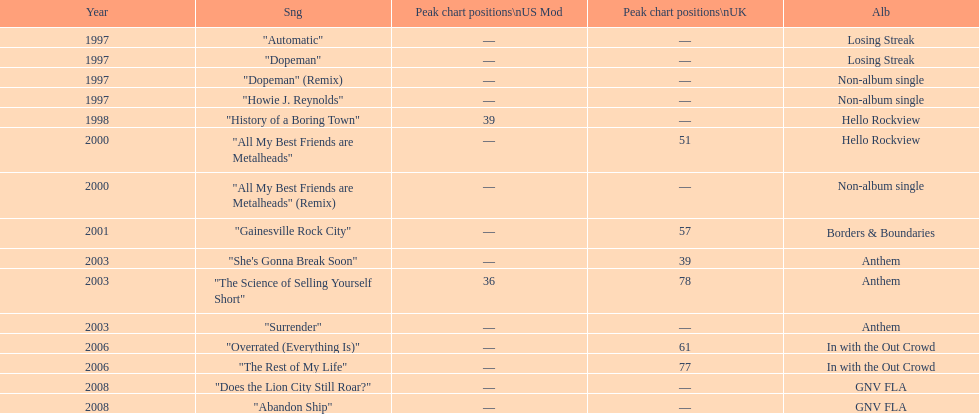Which song came out first? dopeman or surrender. Dopeman. 